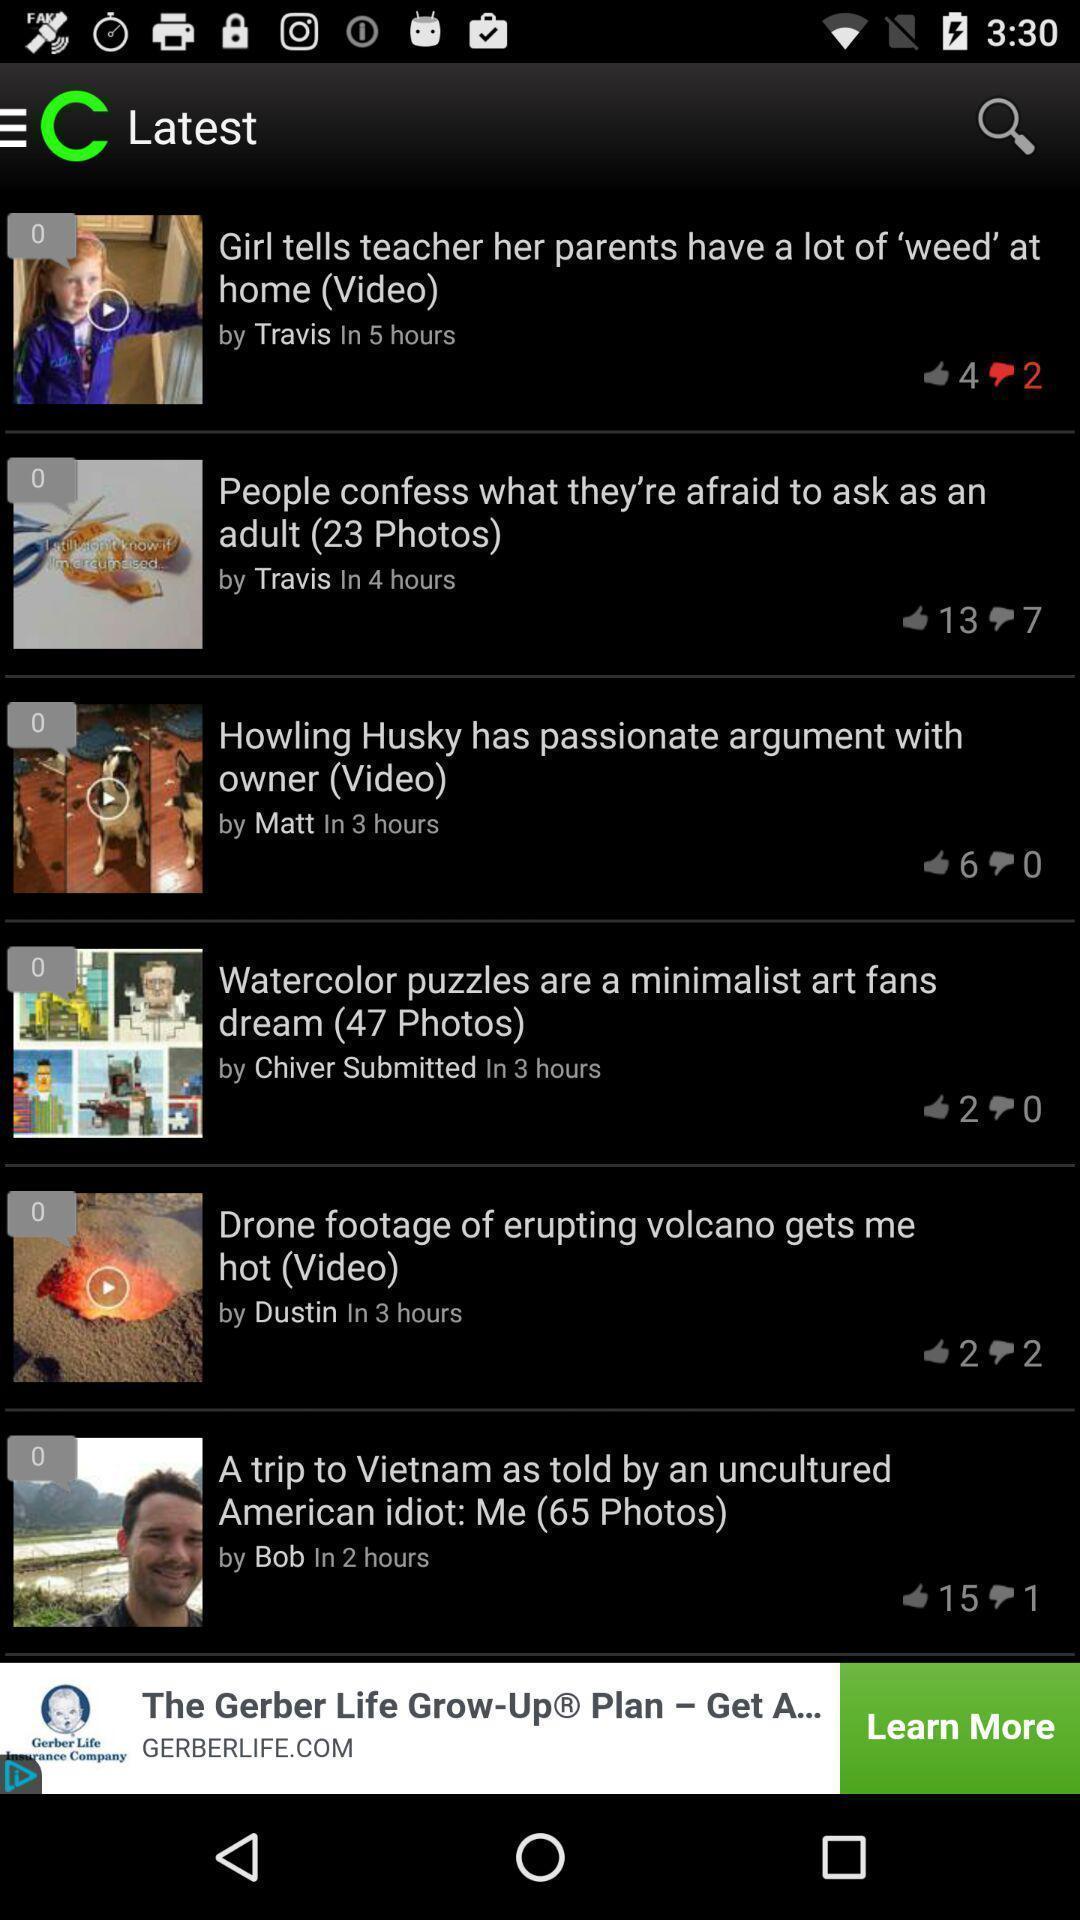Give me a narrative description of this picture. Page showing list of latest videos. 